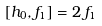<formula> <loc_0><loc_0><loc_500><loc_500>[ h _ { 0 } , f _ { 1 } ] = 2 \, f _ { 1 }</formula> 